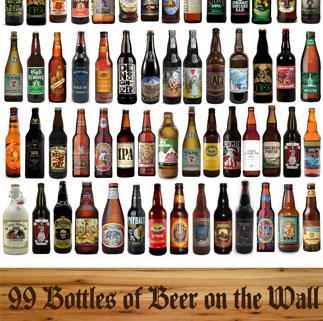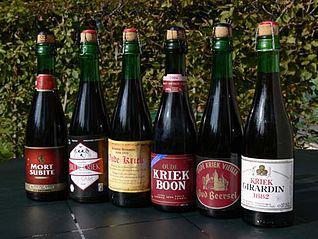The first image is the image on the left, the second image is the image on the right. For the images shown, is this caption "In at least one image there are four rows of beer." true? Answer yes or no. Yes. The first image is the image on the left, the second image is the image on the right. For the images shown, is this caption "The left image contains at least three times as many bottles as the right image, and the bottles in the right image are displayed on a visible flat surface." true? Answer yes or no. Yes. 